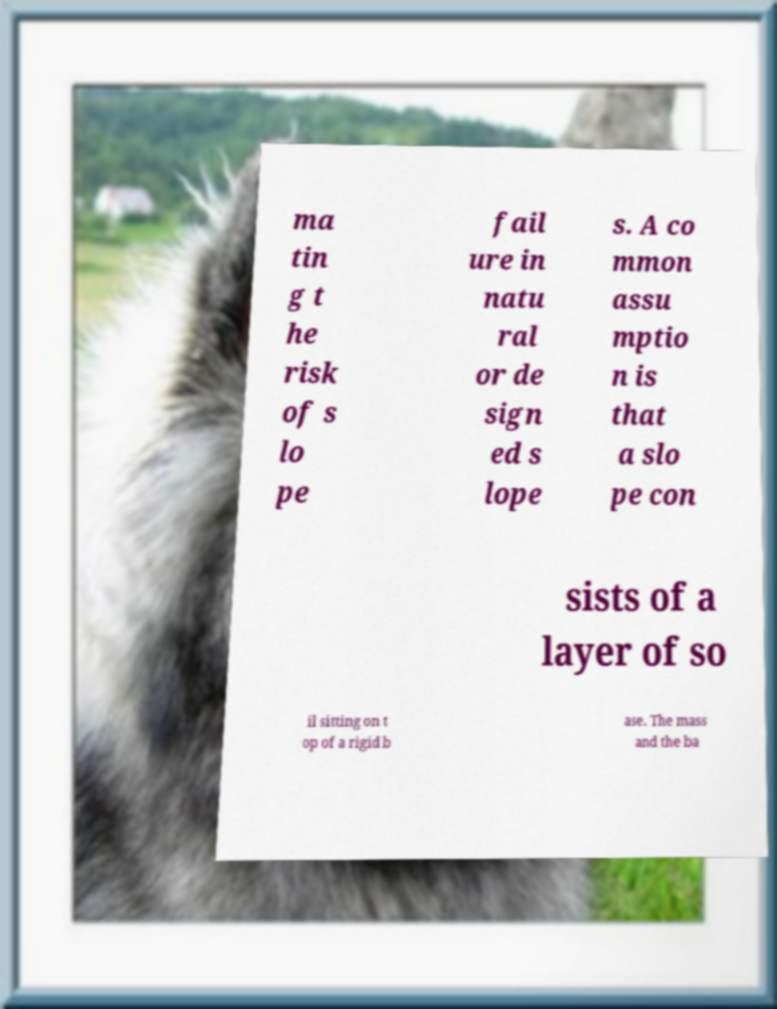There's text embedded in this image that I need extracted. Can you transcribe it verbatim? ma tin g t he risk of s lo pe fail ure in natu ral or de sign ed s lope s. A co mmon assu mptio n is that a slo pe con sists of a layer of so il sitting on t op of a rigid b ase. The mass and the ba 